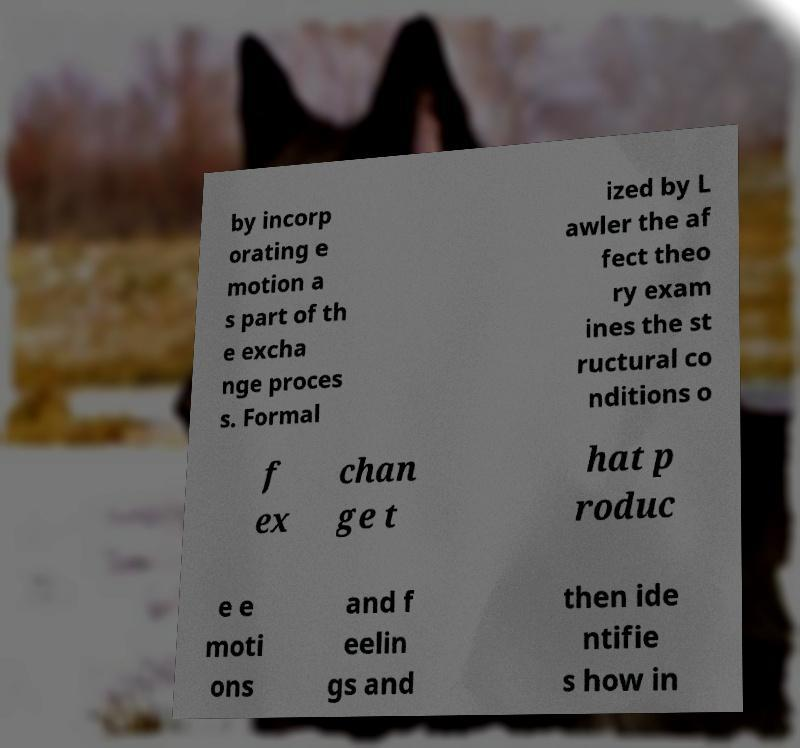Please read and relay the text visible in this image. What does it say? by incorp orating e motion a s part of th e excha nge proces s. Formal ized by L awler the af fect theo ry exam ines the st ructural co nditions o f ex chan ge t hat p roduc e e moti ons and f eelin gs and then ide ntifie s how in 